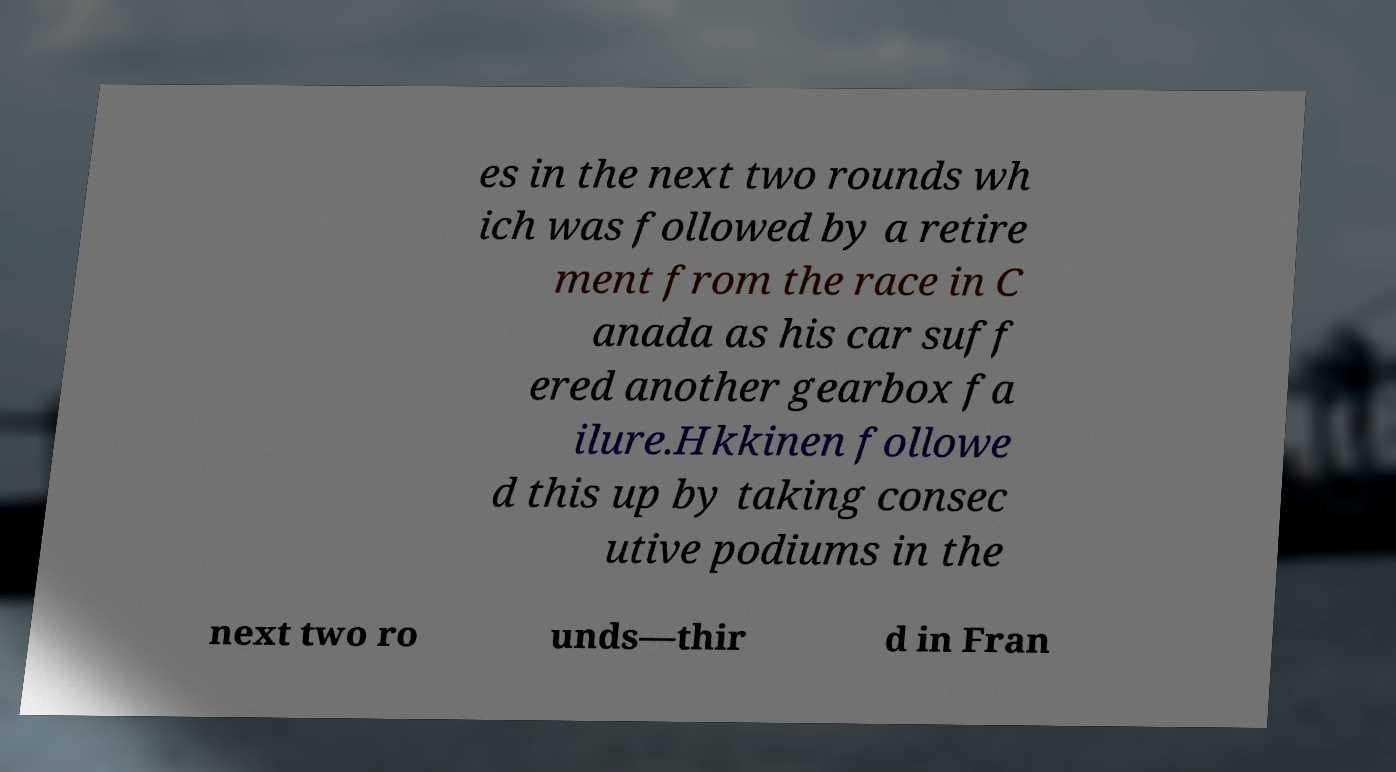Can you read and provide the text displayed in the image?This photo seems to have some interesting text. Can you extract and type it out for me? es in the next two rounds wh ich was followed by a retire ment from the race in C anada as his car suff ered another gearbox fa ilure.Hkkinen followe d this up by taking consec utive podiums in the next two ro unds—thir d in Fran 